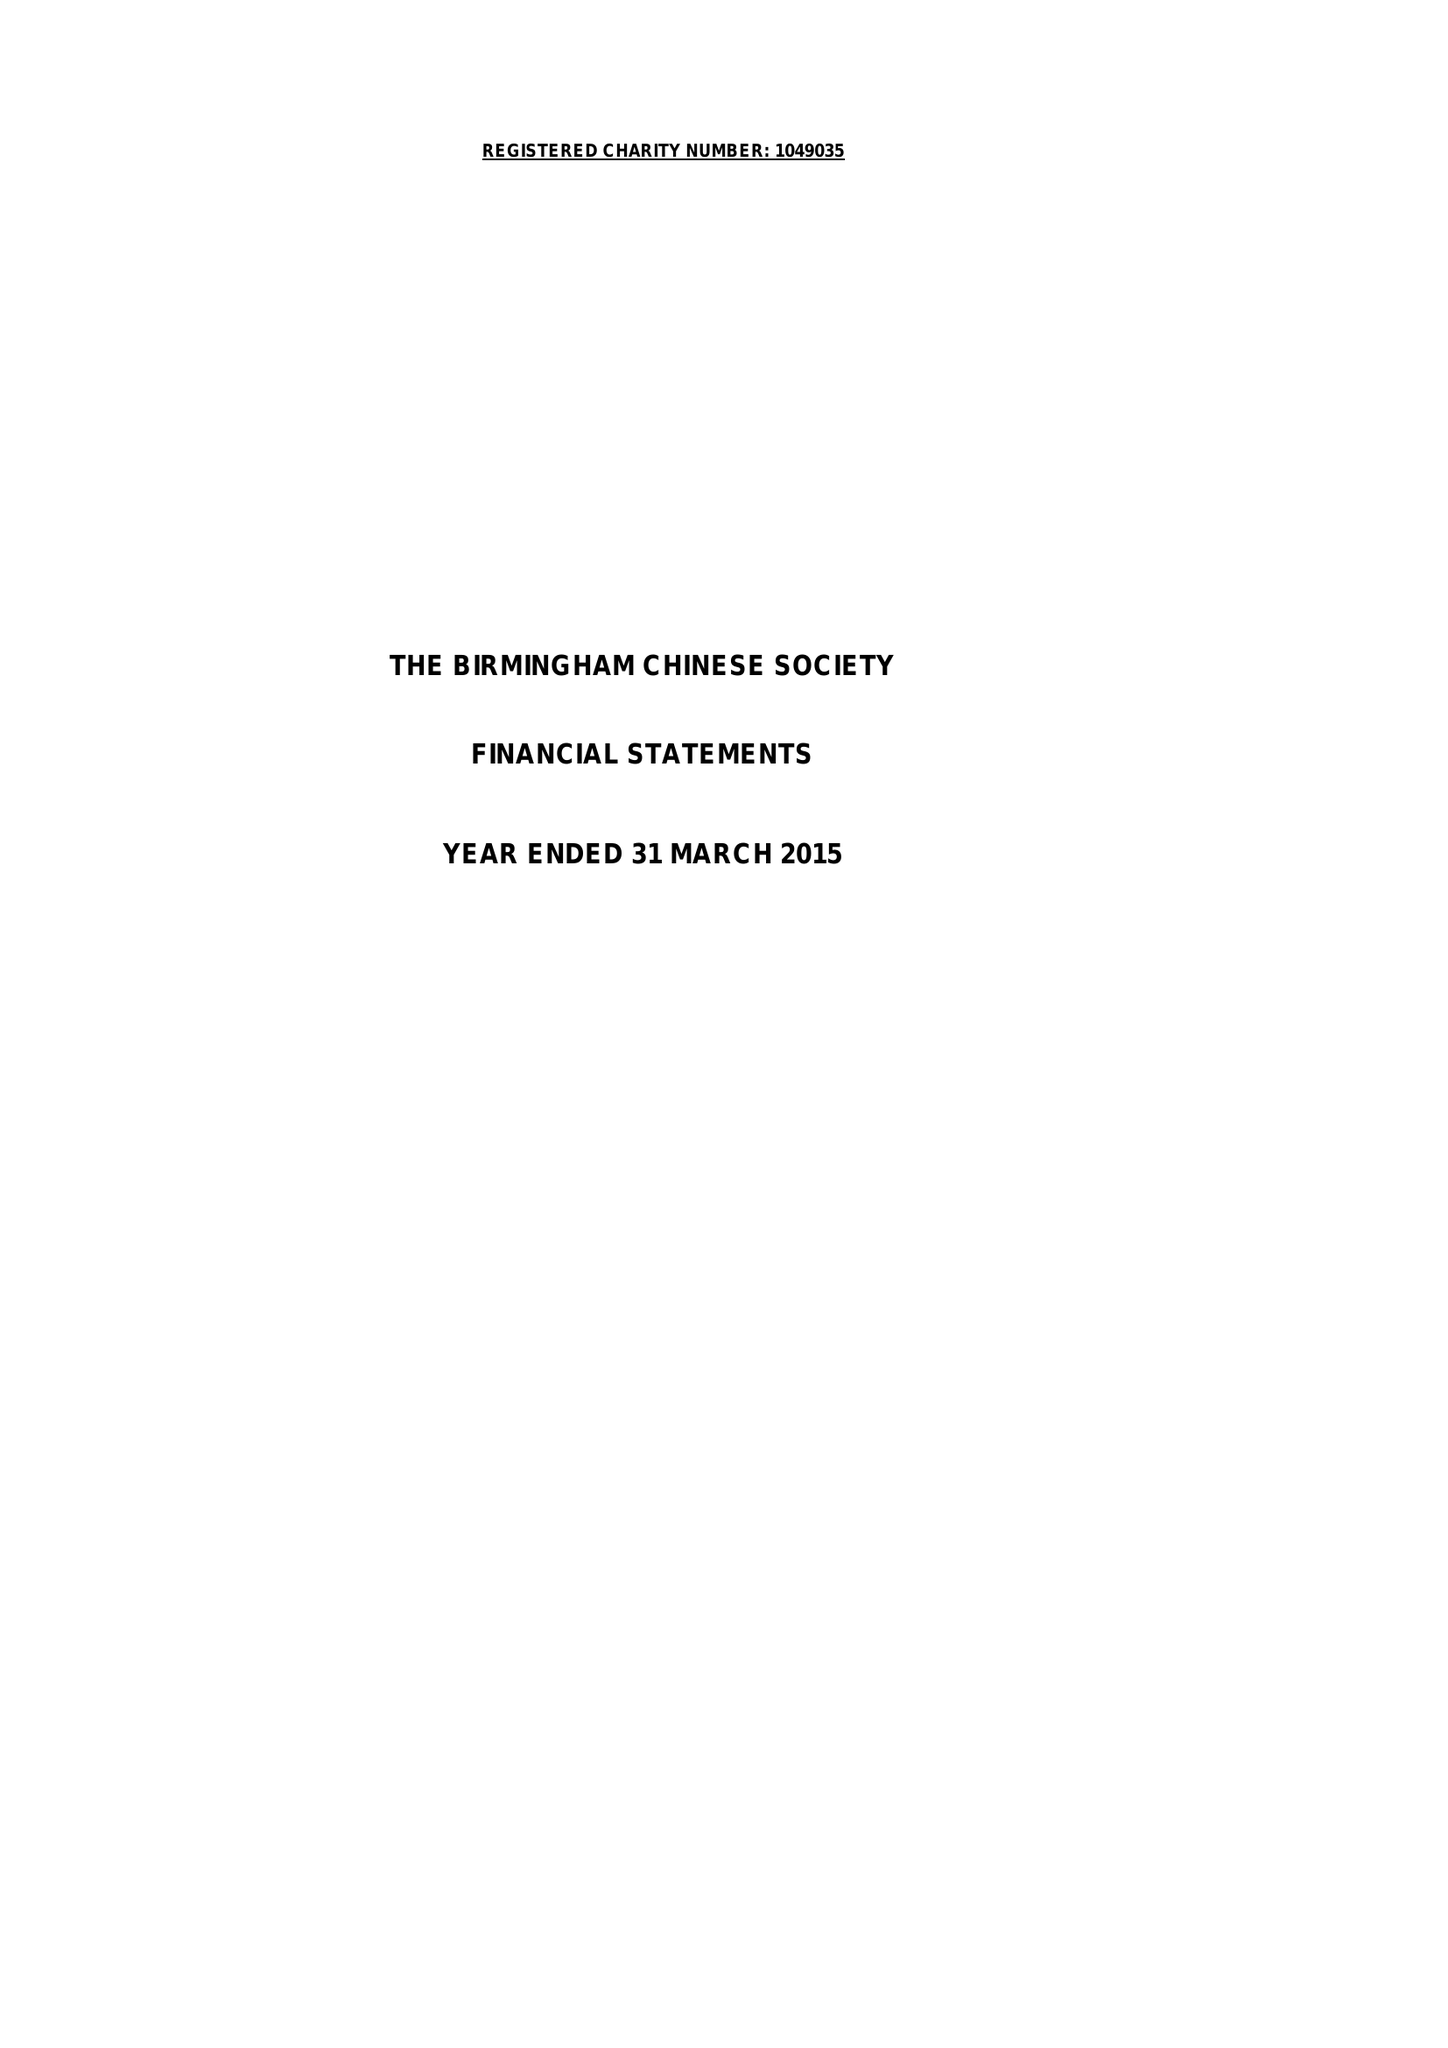What is the value for the charity_name?
Answer the question using a single word or phrase. The Birmingham Chinese Society 